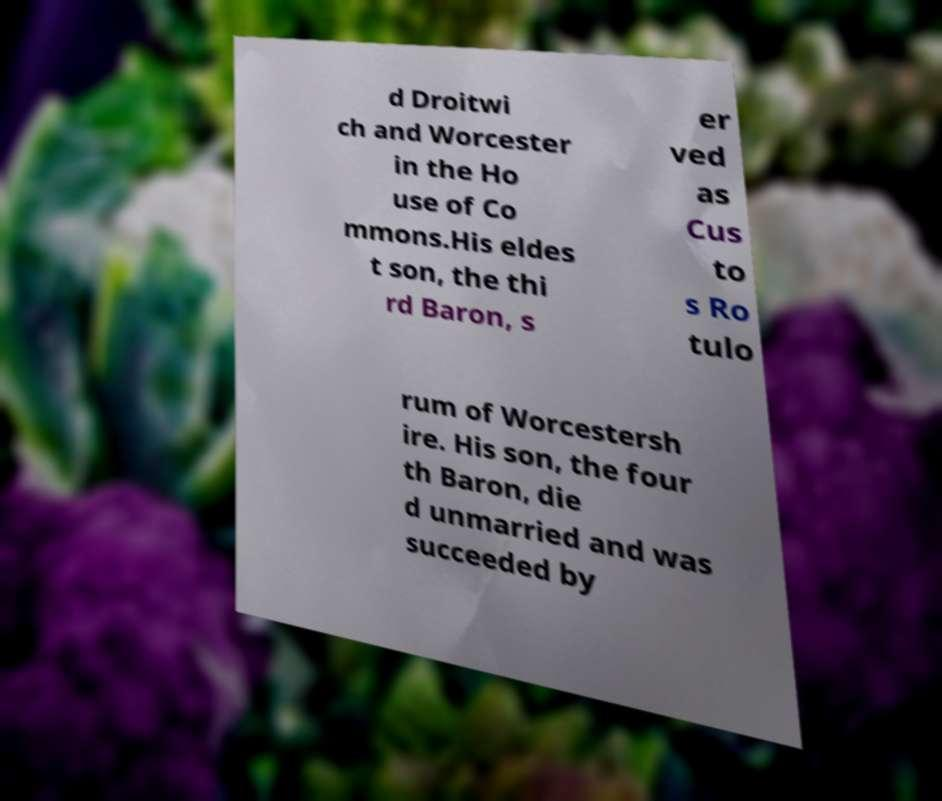Please read and relay the text visible in this image. What does it say? d Droitwi ch and Worcester in the Ho use of Co mmons.His eldes t son, the thi rd Baron, s er ved as Cus to s Ro tulo rum of Worcestersh ire. His son, the four th Baron, die d unmarried and was succeeded by 